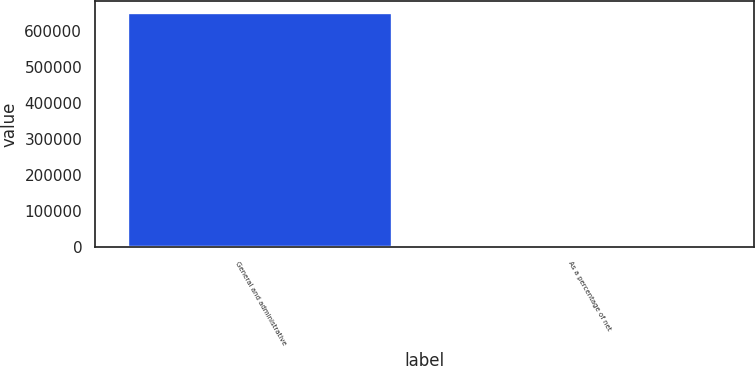Convert chart to OTSL. <chart><loc_0><loc_0><loc_500><loc_500><bar_chart><fcel>General and administrative<fcel>As a percentage of net<nl><fcel>649529<fcel>14.3<nl></chart> 